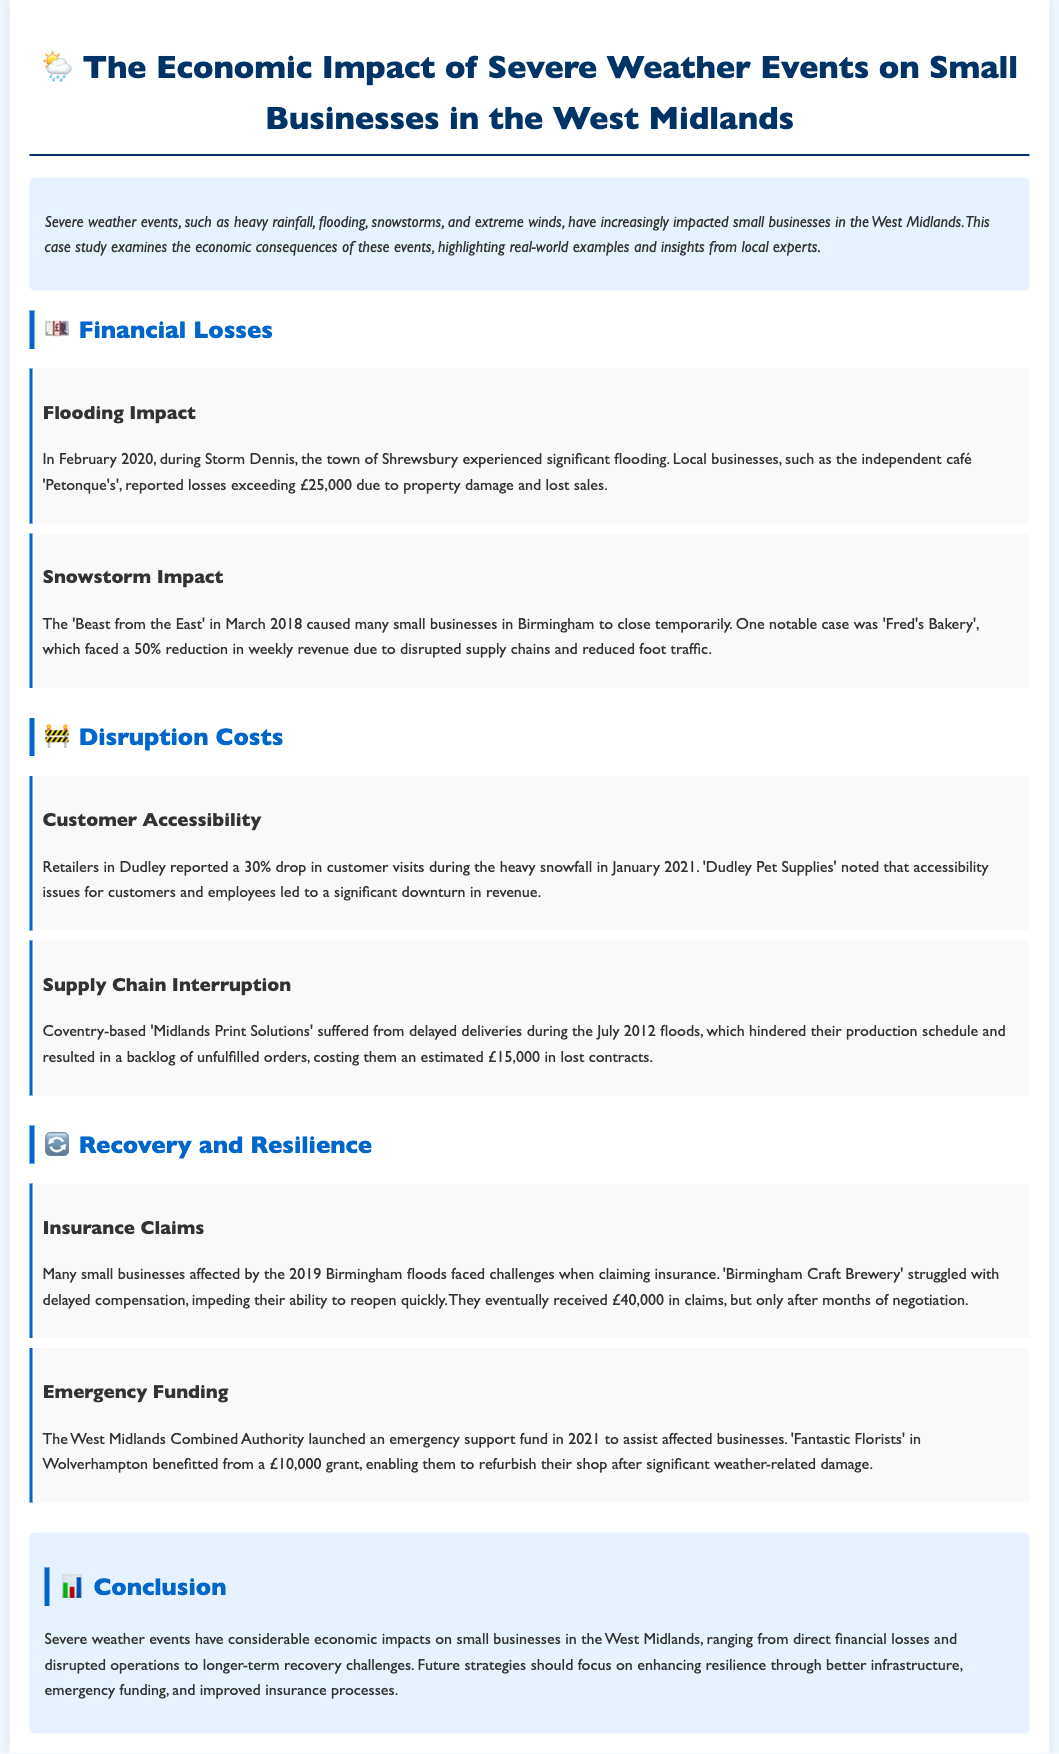What severe weather event caused flooding in February 2020? The document states that Storm Dennis caused significant flooding in February 2020.
Answer: Storm Dennis What was the financial loss reported by 'Petonque's' due to flooding? 'Petonque's' reported losses exceeding £25,000 due to property damage and lost sales during the flooding.
Answer: £25,000 How much did 'Fred's Bakery' experience in revenue reduction during the snowstorm? 'Fred's Bakery' faced a 50% reduction in weekly revenue due to disrupted supply chains and reduced foot traffic during the snowstorm.
Answer: 50% What percentage drop in customer visits did retailers in Dudley report due to heavy snowfall? Retailers in Dudley reported a 30% drop in customer visits during the heavy snowfall in January 2021.
Answer: 30% How much emergency funding did 'Fantastic Florists' receive to refurbish their shop? 'Fantastic Florists' in Wolverhampton benefitted from a £10,000 grant to refurbish their shop after significant weather-related damage.
Answer: £10,000 What was the estimated cost of lost contracts for 'Midlands Print Solutions' due to delayed deliveries? The delays during the July 2012 floods resulted in an estimated £15,000 in lost contracts for 'Midlands Print Solutions'.
Answer: £15,000 How long did it take for 'Birmingham Craft Brewery' to receive their insurance claims? 'Birmingham Craft Brewery' struggled with delayed compensation, receiving £40,000 in claims after months of negotiation.
Answer: Months What type of fund was launched by the West Midlands Combined Authority in 2021? The West Midlands Combined Authority launched an emergency support fund in 2021 to assist affected businesses.
Answer: Emergency support fund What was the primary focus suggested for future strategies to enhance resilience? The conclusion suggests that future strategies should focus on enhancing resilience through better infrastructure, emergency funding, and improved insurance processes.
Answer: Enhancing resilience 